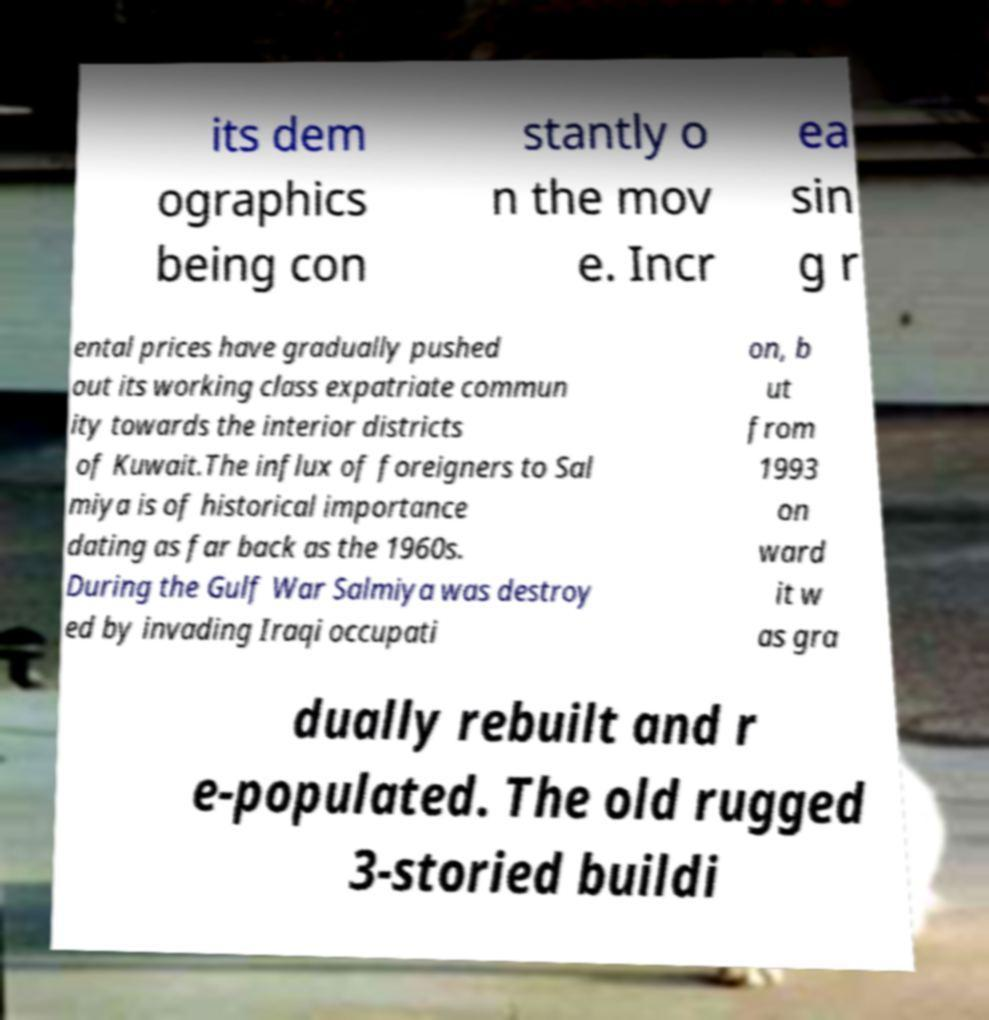Can you read and provide the text displayed in the image?This photo seems to have some interesting text. Can you extract and type it out for me? its dem ographics being con stantly o n the mov e. Incr ea sin g r ental prices have gradually pushed out its working class expatriate commun ity towards the interior districts of Kuwait.The influx of foreigners to Sal miya is of historical importance dating as far back as the 1960s. During the Gulf War Salmiya was destroy ed by invading Iraqi occupati on, b ut from 1993 on ward it w as gra dually rebuilt and r e-populated. The old rugged 3-storied buildi 